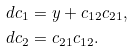Convert formula to latex. <formula><loc_0><loc_0><loc_500><loc_500>d c _ { 1 } & = y + c _ { 1 2 } c _ { 2 1 } , \\ d c _ { 2 } & = c _ { 2 1 } c _ { 1 2 } .</formula> 